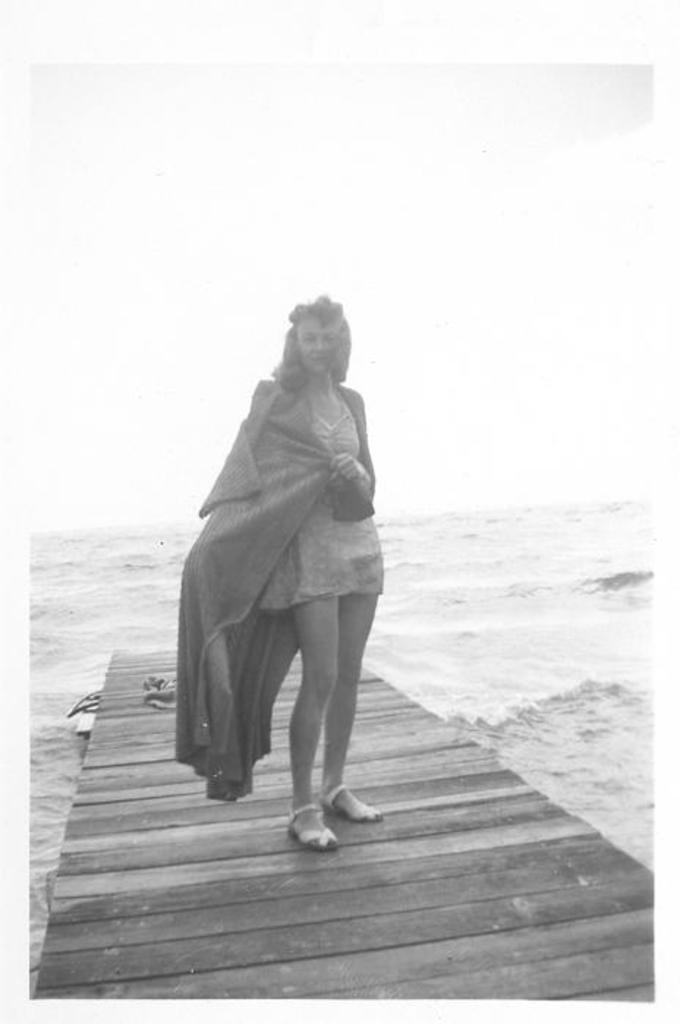Who is present in the image? There is a woman in the image. What is the woman doing in the image? The woman is standing on a bridge. What can be seen in the background of the image? There is water visible in the background of the image. What is the color scheme of the image? The image is in black and white. What type of poison is the woman holding in the image? There is no poison present in the image; the woman is simply standing on a bridge. 